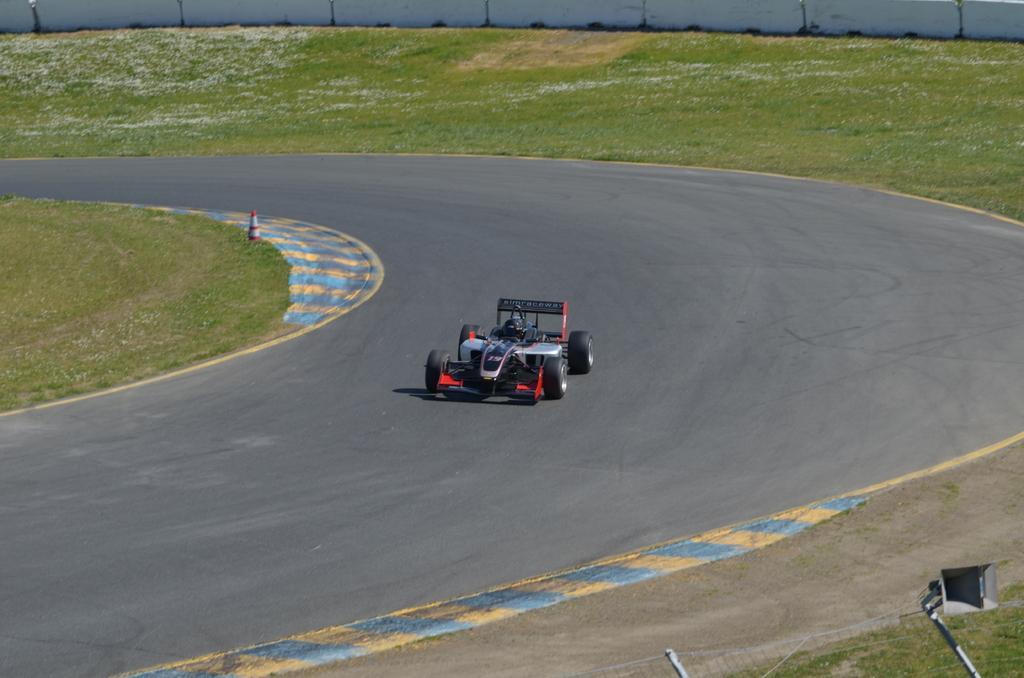What type of vehicle is in the image? There is a sports car in the image. Where is the sports car located? The sports car is on a race track. What can be seen behind the sports car? There is a wall, grass, and a cone barrier behind the sports car. What is in front of the sports car? There is a fence in front of the sports car. Can you hear the sound of a hose in the image? There is no hose present in the image, so it is not possible to hear its sound. 